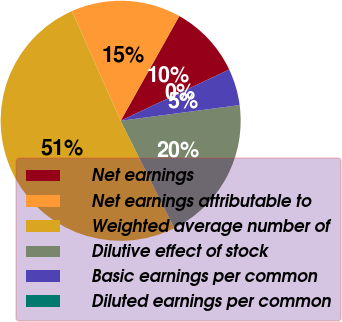Convert chart to OTSL. <chart><loc_0><loc_0><loc_500><loc_500><pie_chart><fcel>Net earnings<fcel>Net earnings attributable to<fcel>Weighted average number of<fcel>Dilutive effect of stock<fcel>Basic earnings per common<fcel>Diluted earnings per common<nl><fcel>9.86%<fcel>14.78%<fcel>50.72%<fcel>19.71%<fcel>4.93%<fcel>0.0%<nl></chart> 